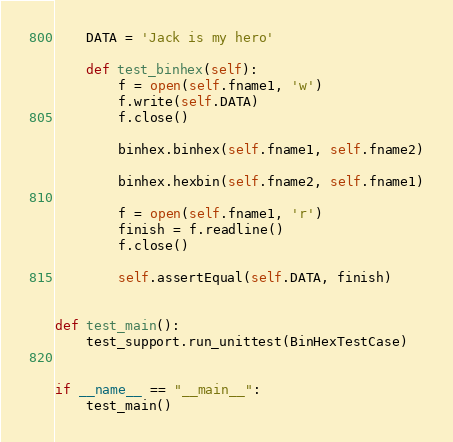<code> <loc_0><loc_0><loc_500><loc_500><_Python_>    DATA = 'Jack is my hero'

    def test_binhex(self):
        f = open(self.fname1, 'w')
        f.write(self.DATA)
        f.close()

        binhex.binhex(self.fname1, self.fname2)

        binhex.hexbin(self.fname2, self.fname1)

        f = open(self.fname1, 'r')
        finish = f.readline()
        f.close()

        self.assertEqual(self.DATA, finish)


def test_main():
    test_support.run_unittest(BinHexTestCase)


if __name__ == "__main__":
    test_main()
</code> 